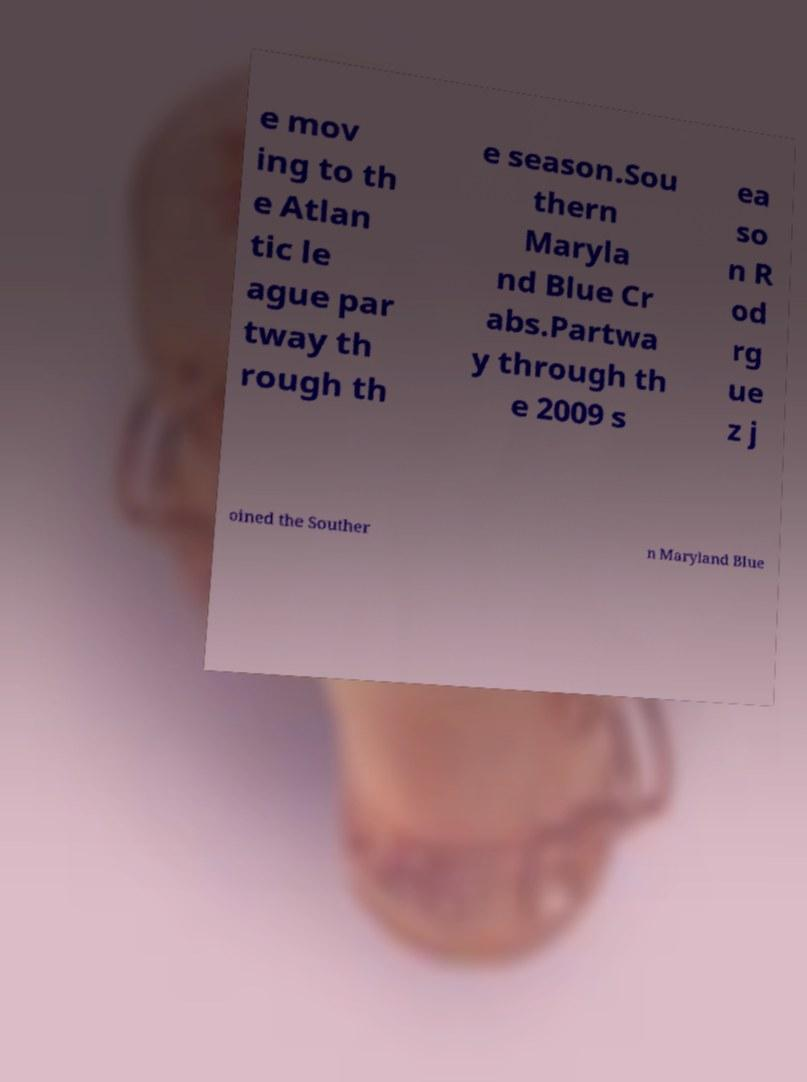Please read and relay the text visible in this image. What does it say? e mov ing to th e Atlan tic le ague par tway th rough th e season.Sou thern Maryla nd Blue Cr abs.Partwa y through th e 2009 s ea so n R od rg ue z j oined the Souther n Maryland Blue 